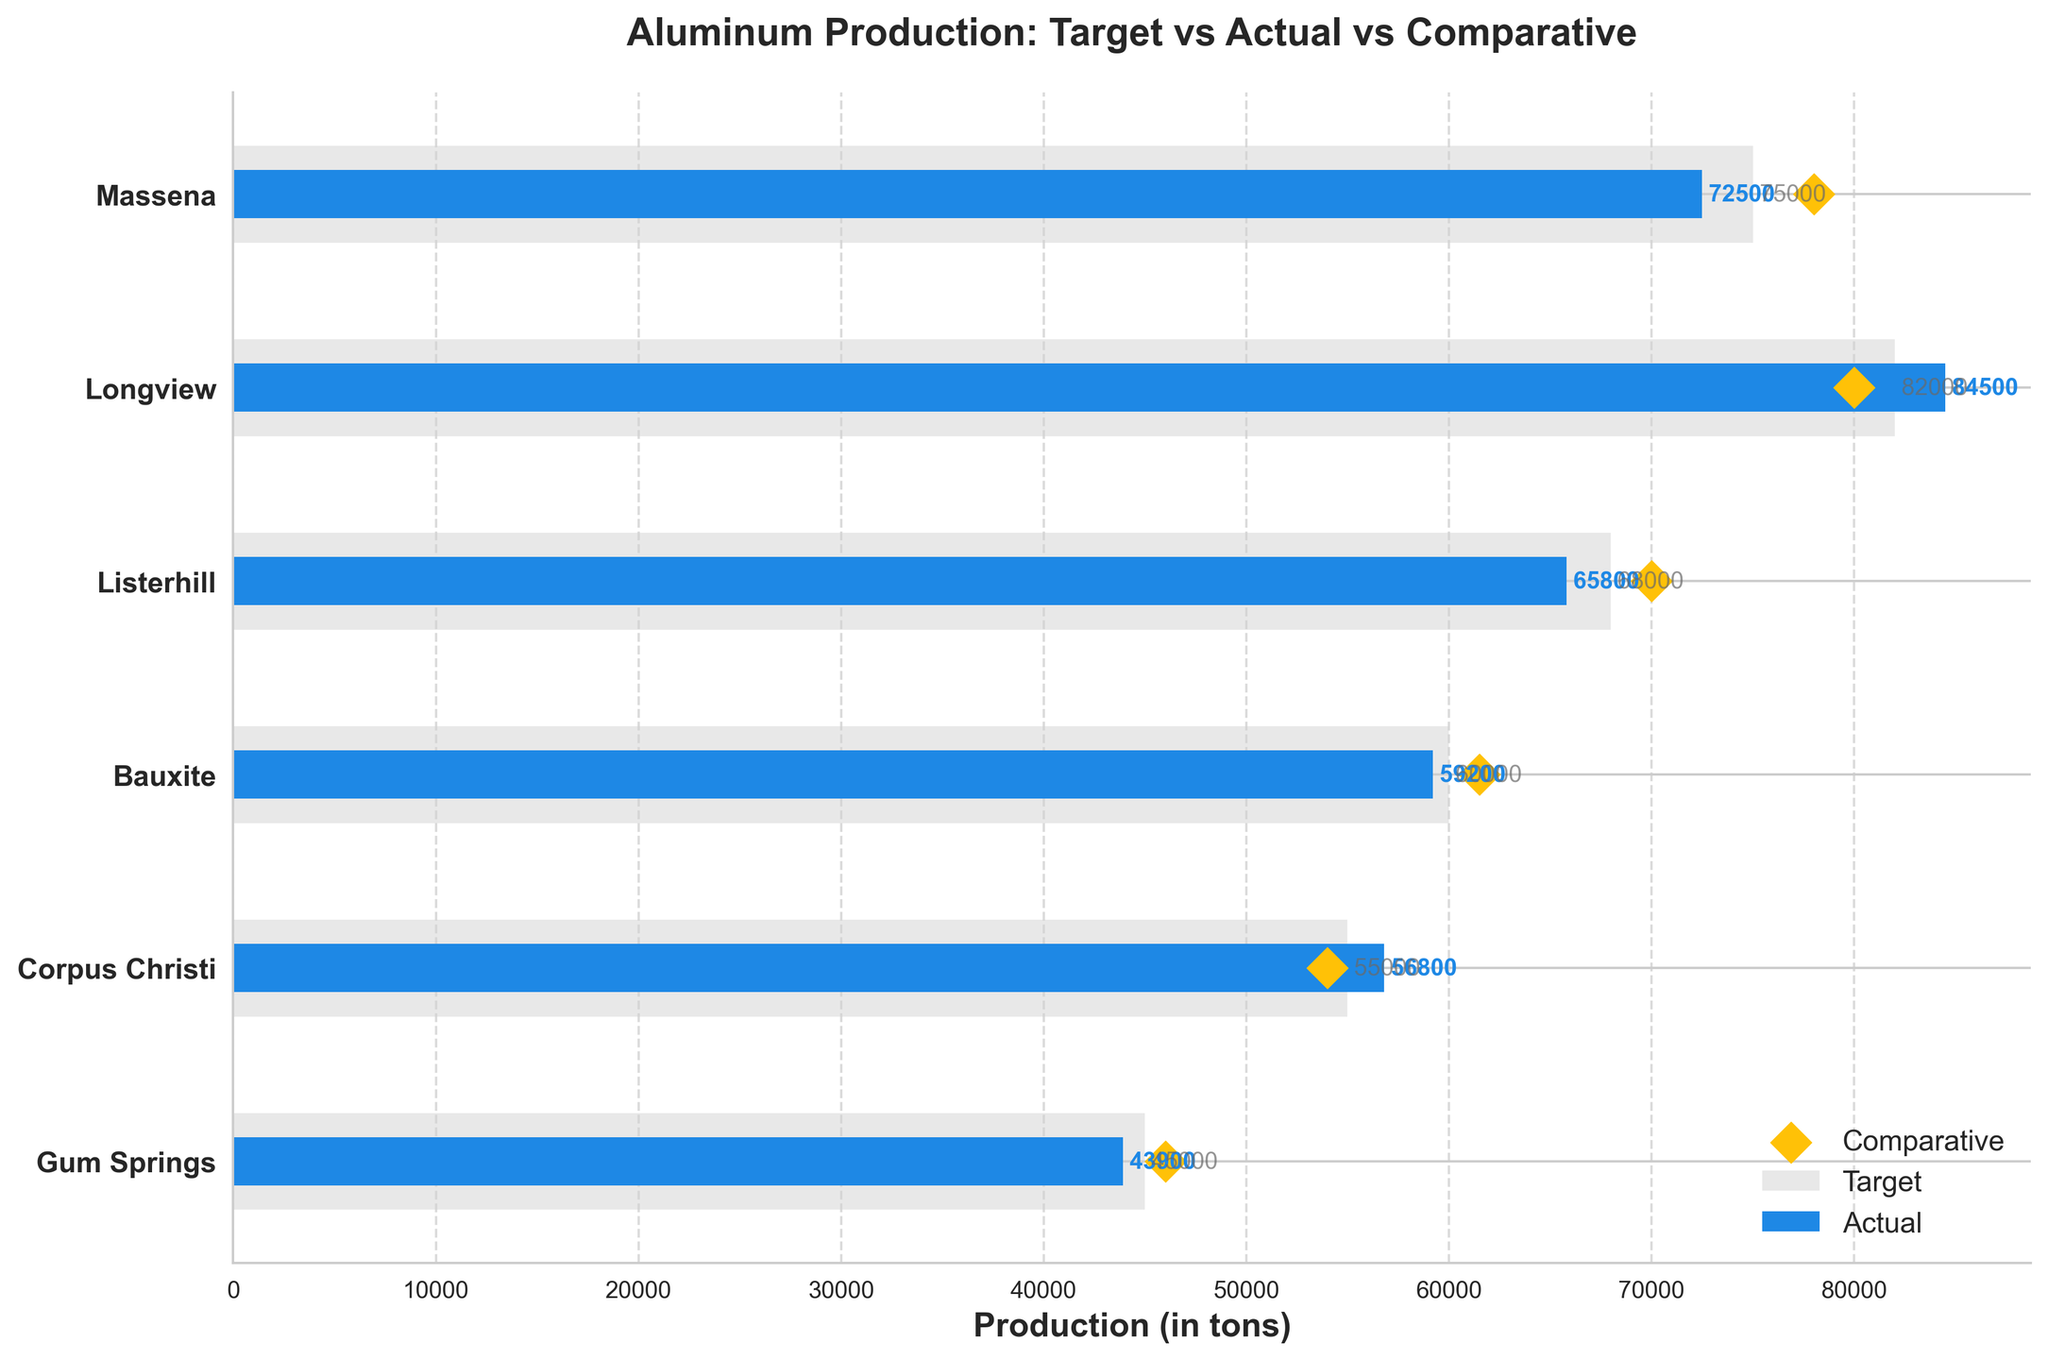What is the title of the chart? The title is displayed at the top of the chart, emphasizing the main focus of the figure.
Answer: Aluminum Production: Target vs Actual vs Comparative How many plants are compared in the chart? By observing the y-axis, we can count that there are six plants listed.
Answer: Six Which plant had the highest actual production? By comparing the blue bars representing actual production, we can see that Longview had the highest actual production.
Answer: Longview Did any plant exceed its target production? If yes, which one? By comparing the grey bars (targets) with the blue bars (actuals), we observe that the actual production for Longview (84,500) exceeded its target (82,000).
Answer: Yes, Longview What is the difference between the actual and target production for Massena? Subtract the actual production from the target production for Massena: 75,000 - 72,500 = 2,500 tons.
Answer: 2,500 tons Which plant had the actual production closest to its comparative value? By comparing the blue bars (actuals) with the gold diamonds (comparatives), Corpus Christi had the actual production (56,800) closest to its comparative value (54,000), with a difference of only 2,800 tons.
Answer: Corpus Christi What is the average target production across all plants? Sum up all target productions and divide by the number of plants: (75,000 + 82,000 + 68,000 + 60,000 + 55,000 + 45,000) / 6 = 64,166.67
Answer: 64,166.67 tons How does the actual production of Gum Springs compare to its comparative value? The chart shows that the actual production (43,900) is lower than the comparative value (46,000) for Gum Springs.
Answer: Lower Which plant had the smallest difference between its target and actual production? By calculating the difference for each plant, we see that Corpus Christi has the smallest difference (55,000 - 56,800 = 1,800 tons).
Answer: Corpus Christi What is the total actual production across all plants? Sum all actual productions: 72,500 + 84,500 + 65,800 + 59,200 + 56,800 + 43,900 = 382,700 tons.
Answer: 382,700 tons 